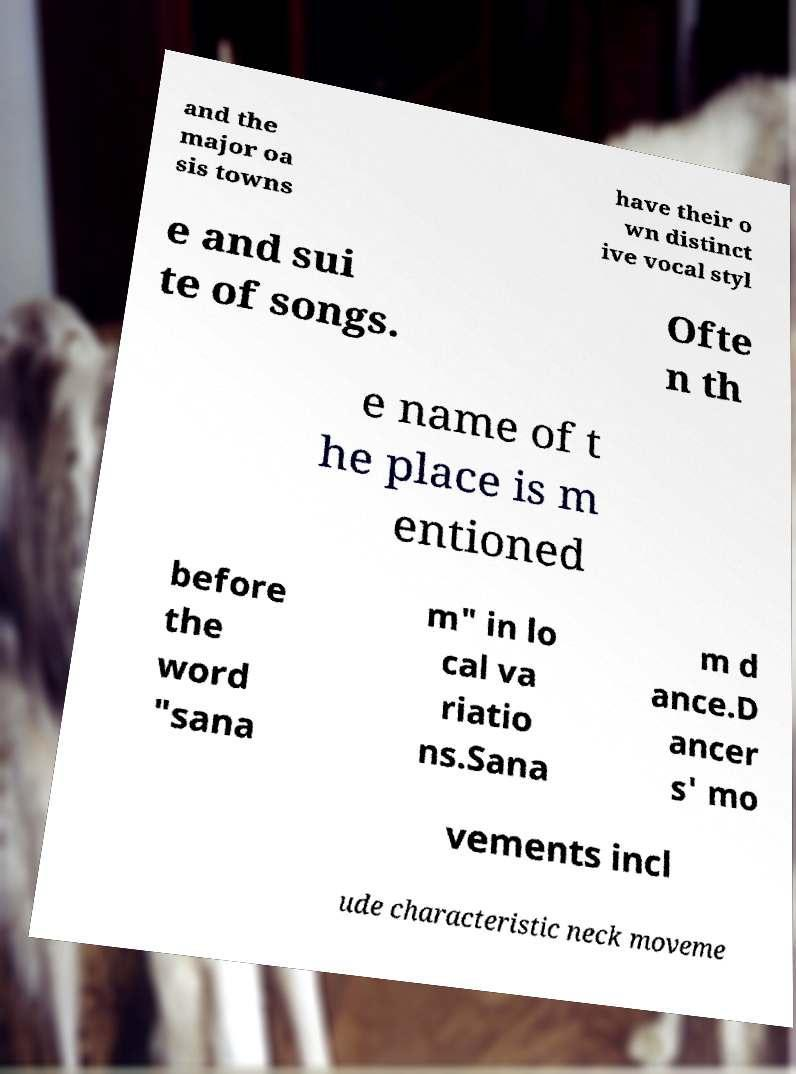For documentation purposes, I need the text within this image transcribed. Could you provide that? and the major oa sis towns have their o wn distinct ive vocal styl e and sui te of songs. Ofte n th e name of t he place is m entioned before the word "sana m" in lo cal va riatio ns.Sana m d ance.D ancer s' mo vements incl ude characteristic neck moveme 